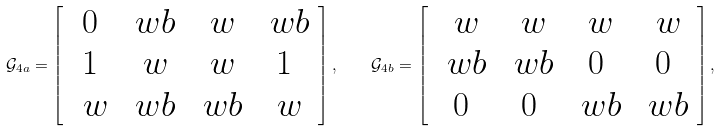Convert formula to latex. <formula><loc_0><loc_0><loc_500><loc_500>\mathcal { G } _ { 4 a } = \left [ \begin{array} { c c c c } 0 & \ w b & \ w & \ w b \\ 1 & \ w & \ w & 1 \\ \ w & \ w b & \ w b & \ w \end{array} \right ] , \quad \mathcal { G } _ { 4 b } = \left [ \begin{array} { c c c c } \ w & \ w & \ w & \ w \\ \ w b & \ w b & 0 & 0 \\ 0 & 0 & \ w b & \ w b \end{array} \right ] ,</formula> 